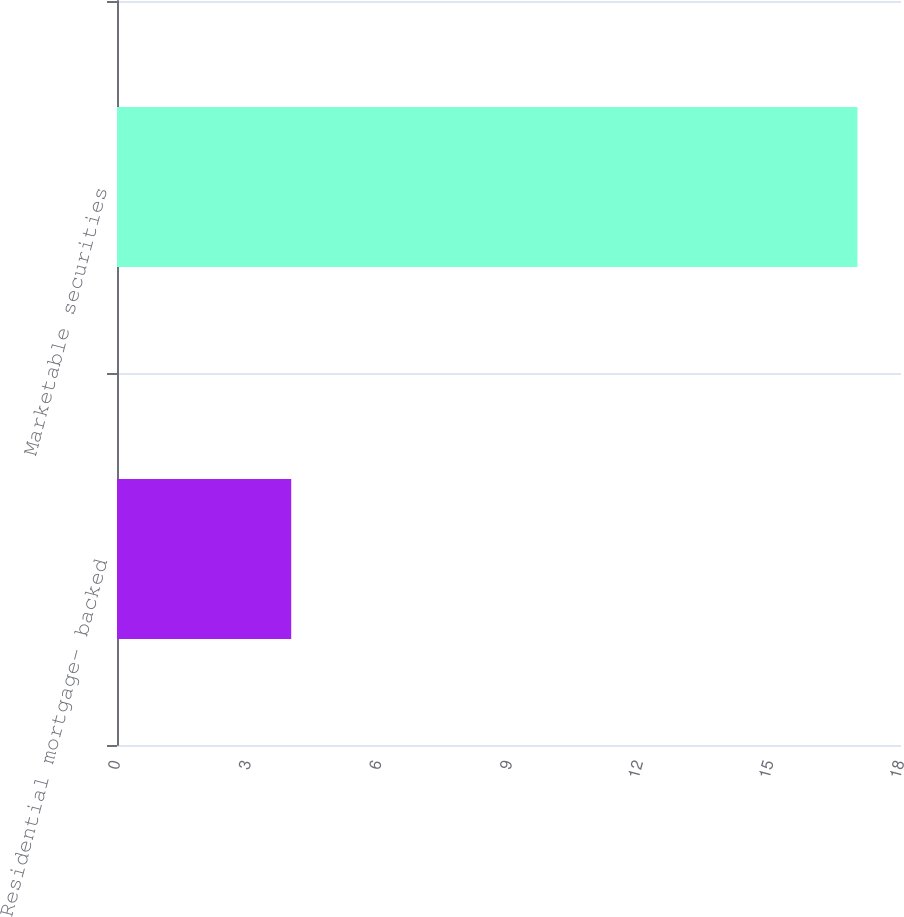<chart> <loc_0><loc_0><loc_500><loc_500><bar_chart><fcel>Residential mortgage- backed<fcel>Marketable securities<nl><fcel>4<fcel>17<nl></chart> 